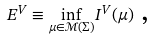Convert formula to latex. <formula><loc_0><loc_0><loc_500><loc_500>E ^ { V } \equiv \underset { \mu \in \mathcal { M } ( \Sigma ) } { \inf } I ^ { V } ( \mu ) \text { , \ \ }</formula> 